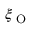<formula> <loc_0><loc_0><loc_500><loc_500>\xi _ { O }</formula> 